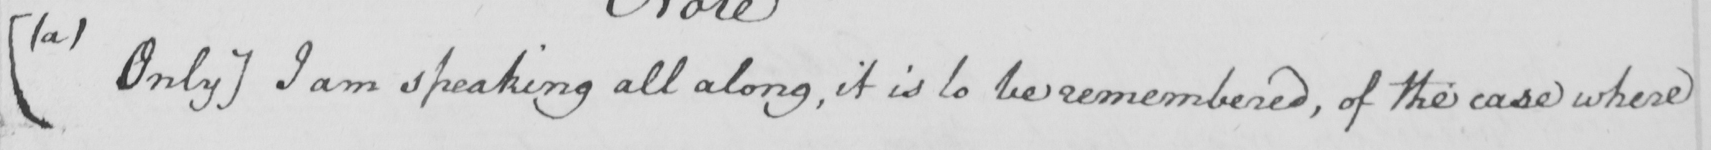Can you read and transcribe this handwriting? [  ( a )  Only ]  I am speaking all along , it is to be remembered , of the case where 